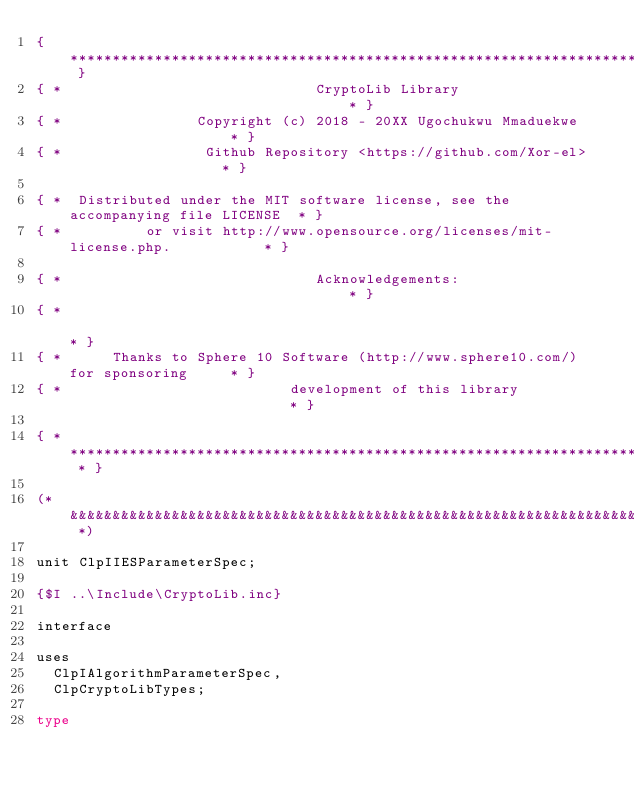<code> <loc_0><loc_0><loc_500><loc_500><_Pascal_>{ *********************************************************************************** }
{ *                              CryptoLib Library                                  * }
{ *                Copyright (c) 2018 - 20XX Ugochukwu Mmaduekwe                    * }
{ *                 Github Repository <https://github.com/Xor-el>                   * }

{ *  Distributed under the MIT software license, see the accompanying file LICENSE  * }
{ *          or visit http://www.opensource.org/licenses/mit-license.php.           * }

{ *                              Acknowledgements:                                  * }
{ *                                                                                 * }
{ *      Thanks to Sphere 10 Software (http://www.sphere10.com/) for sponsoring     * }
{ *                           development of this library                           * }

{ * ******************************************************************************* * }

(* &&&&&&&&&&&&&&&&&&&&&&&&&&&&&&&&&&&&&&&&&&&&&&&&&&&&&&&&&&&&&&&&&&&&&&&&&&&&&&&&& *)

unit ClpIIESParameterSpec;

{$I ..\Include\CryptoLib.inc}

interface

uses
  ClpIAlgorithmParameterSpec,
  ClpCryptoLibTypes;

type</code> 